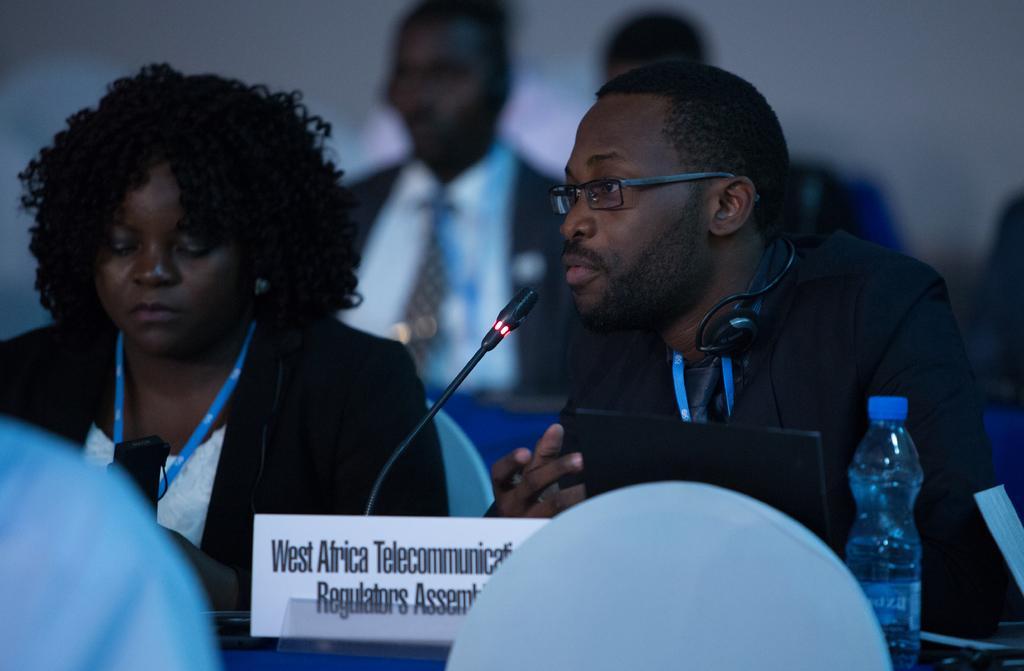Could you give a brief overview of what you see in this image? In this picture we can see four persons are sitting on chairs, there is a microphone and a name board in the front, on the right side there is a water bottle, a man on the right side is wearing spectacles and headphones, there is a blurry background. 